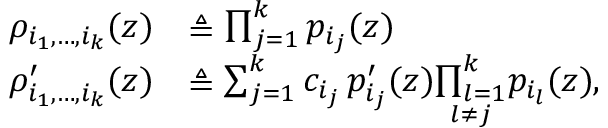<formula> <loc_0><loc_0><loc_500><loc_500>\begin{array} { r l } { \rho _ { i _ { 1 } , \hdots , i _ { k } } ( z ) } & { \triangle q \prod _ { j = 1 } ^ { k } p _ { i _ { j } } ( z ) } \\ { \rho _ { i _ { 1 } , \hdots , i _ { k } } ^ { \prime } ( z ) } & { \triangle q \sum _ { j = 1 } ^ { k } c _ { i _ { j } } \, p _ { i _ { j } } ^ { \prime } ( z ) \underset { l \ne j } { \prod _ { l = 1 } ^ { k } } p _ { i _ { l } } ( z ) , } \end{array}</formula> 